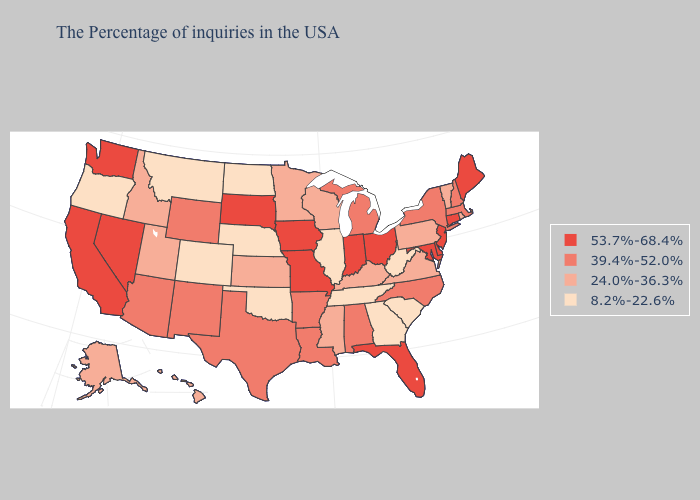Does Oklahoma have the lowest value in the USA?
Answer briefly. Yes. What is the value of Idaho?
Write a very short answer. 24.0%-36.3%. Among the states that border Georgia , does Florida have the lowest value?
Concise answer only. No. Does West Virginia have a higher value than New Jersey?
Short answer required. No. What is the value of Delaware?
Keep it brief. 53.7%-68.4%. What is the value of Mississippi?
Quick response, please. 24.0%-36.3%. Which states have the lowest value in the West?
Keep it brief. Colorado, Montana, Oregon. Which states have the lowest value in the USA?
Answer briefly. South Carolina, West Virginia, Georgia, Tennessee, Illinois, Nebraska, Oklahoma, North Dakota, Colorado, Montana, Oregon. What is the value of Iowa?
Short answer required. 53.7%-68.4%. Does Delaware have the same value as Maine?
Short answer required. Yes. What is the value of Wisconsin?
Write a very short answer. 24.0%-36.3%. What is the lowest value in the MidWest?
Quick response, please. 8.2%-22.6%. Does Colorado have the highest value in the USA?
Keep it brief. No. What is the value of Connecticut?
Quick response, please. 53.7%-68.4%. Which states have the lowest value in the USA?
Be succinct. South Carolina, West Virginia, Georgia, Tennessee, Illinois, Nebraska, Oklahoma, North Dakota, Colorado, Montana, Oregon. 